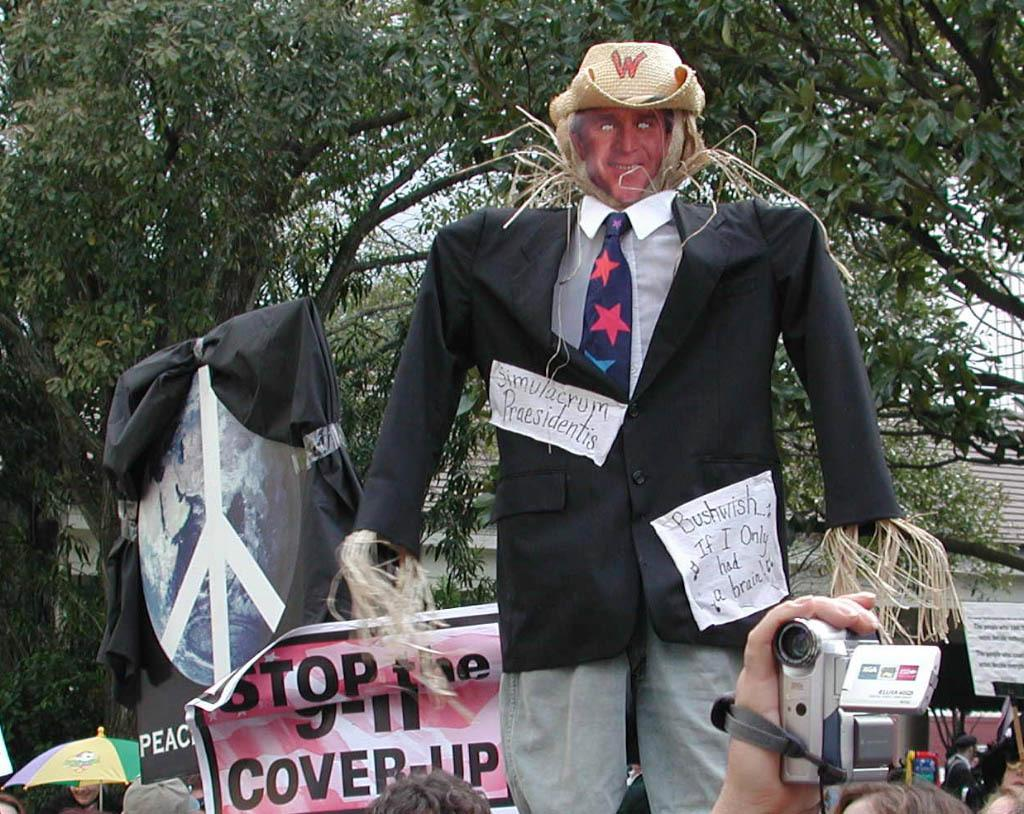What is the person in the image holding? The person in the image is holding a camera. What is the doll wearing in the image? The doll is wearing man's clothes in the image. What type of plant can be seen in the image? There is a tree visible in the image. What is visible in the background of the image? The sky is visible in the image. What type of animal is sitting on the hand in the image? There is no animal sitting on a hand in the image. 